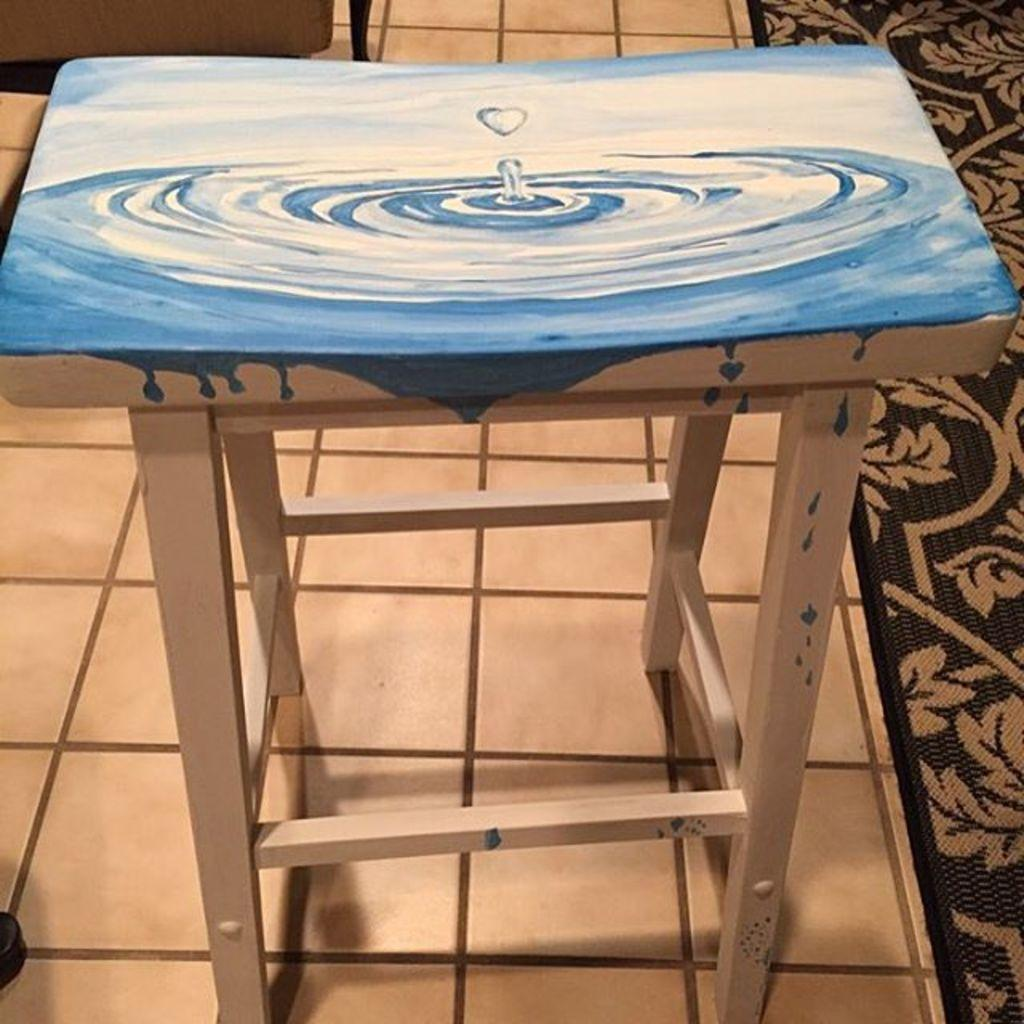What type of furniture is present in the image? There is a table in the image. Where is the table located? The table is on a floor. What can be seen on the right side of the image? There is a mat on the right side of the image. What type of drum is being played by the bears in the image? There are no bears or drums present in the image. 